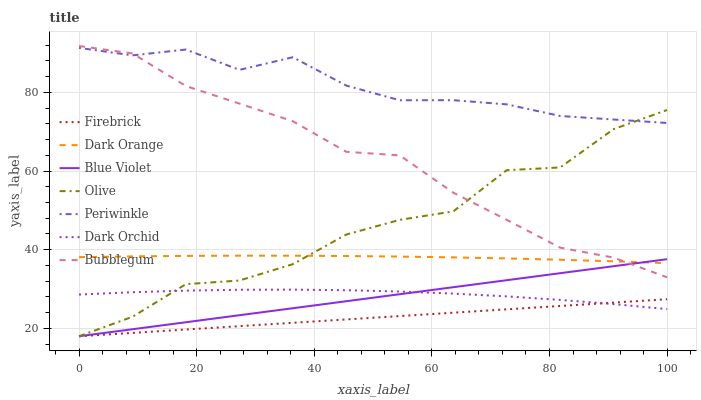Does Firebrick have the minimum area under the curve?
Answer yes or no. Yes. Does Periwinkle have the maximum area under the curve?
Answer yes or no. Yes. Does Dark Orchid have the minimum area under the curve?
Answer yes or no. No. Does Dark Orchid have the maximum area under the curve?
Answer yes or no. No. Is Firebrick the smoothest?
Answer yes or no. Yes. Is Olive the roughest?
Answer yes or no. Yes. Is Dark Orchid the smoothest?
Answer yes or no. No. Is Dark Orchid the roughest?
Answer yes or no. No. Does Dark Orchid have the lowest value?
Answer yes or no. No. Does Bubblegum have the highest value?
Answer yes or no. Yes. Does Dark Orchid have the highest value?
Answer yes or no. No. Is Firebrick less than Dark Orange?
Answer yes or no. Yes. Is Dark Orange greater than Firebrick?
Answer yes or no. Yes. Does Firebrick intersect Dark Orange?
Answer yes or no. No. 